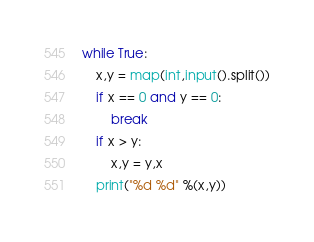<code> <loc_0><loc_0><loc_500><loc_500><_Python_>while True:
    x,y = map(int,input().split())
    if x == 0 and y == 0:
        break
    if x > y:
        x,y = y,x
    print("%d %d" %(x,y))
</code> 